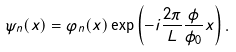<formula> <loc_0><loc_0><loc_500><loc_500>\psi _ { n } ( x ) = \varphi _ { n } ( x ) \exp { \left ( - i \frac { 2 \pi } { L } \frac { \phi } { \phi _ { 0 } } x \right ) } \, .</formula> 